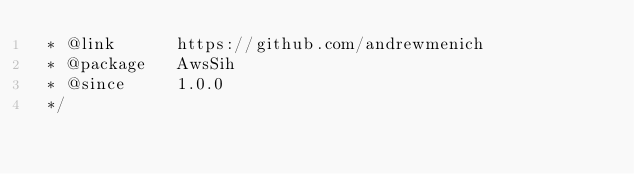<code> <loc_0><loc_0><loc_500><loc_500><_CSS_> * @link      https://github.com/andrewmenich
 * @package   AwsSih
 * @since     1.0.0
 */
</code> 